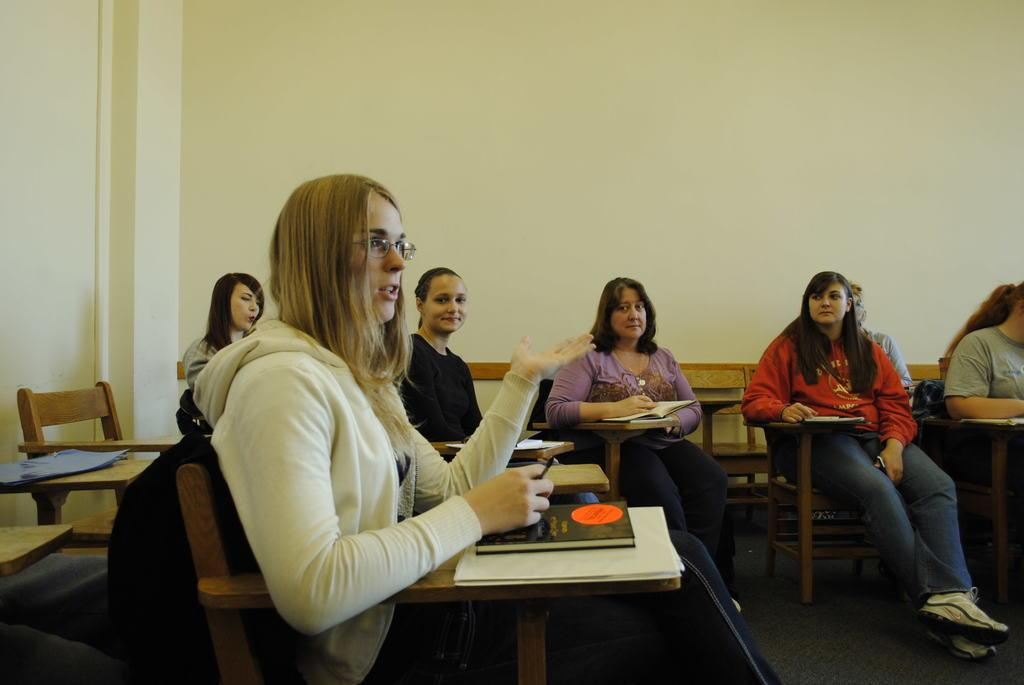What are the persons in the image doing? The persons in the image are sitting on chairs. What objects can be seen in the image besides the chairs? There are tables and books visible in the image. What part of the room can be seen in the image? The floor is visible in the image. What is present in the background of the image? There is a wall in the background of the image. What type of view can be seen through the window in the image? There is no window present in the image, so it is not possible to determine what type of view might be seen through it. 